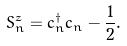Convert formula to latex. <formula><loc_0><loc_0><loc_500><loc_500>S _ { n } ^ { z } = c _ { n } ^ { \dagger } c _ { n } - \frac { 1 } { 2 } .</formula> 